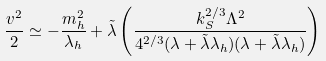<formula> <loc_0><loc_0><loc_500><loc_500>\frac { v ^ { 2 } } { 2 } \simeq - \frac { m ^ { 2 } _ { h } } { \lambda _ { h } } + \tilde { \lambda } \left ( \frac { k ^ { 2 / 3 } _ { S } \Lambda ^ { 2 } } { 4 ^ { 2 / 3 } ( \lambda + \tilde { \lambda } \lambda _ { h } ) ( \lambda + \tilde { \lambda } \lambda _ { h } ) } \right )</formula> 